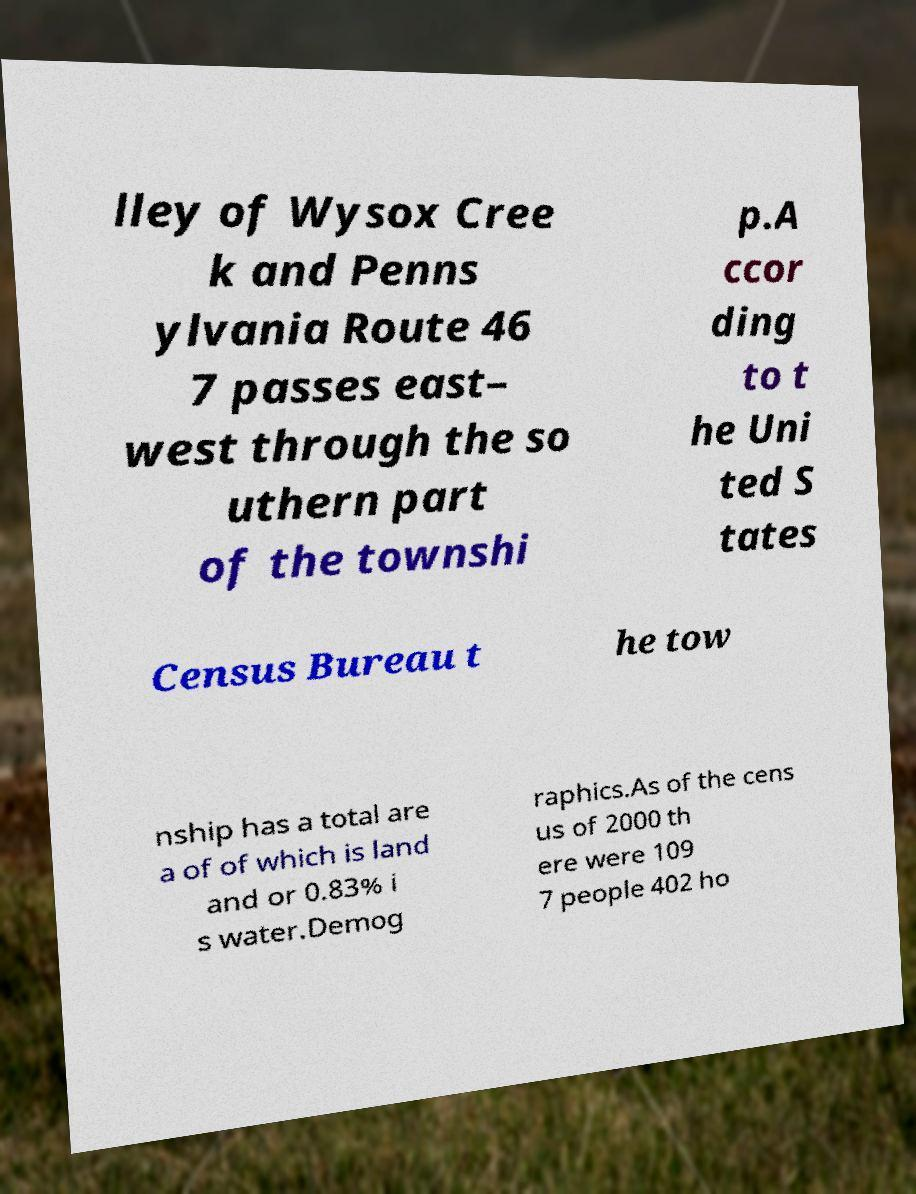For documentation purposes, I need the text within this image transcribed. Could you provide that? lley of Wysox Cree k and Penns ylvania Route 46 7 passes east– west through the so uthern part of the townshi p.A ccor ding to t he Uni ted S tates Census Bureau t he tow nship has a total are a of of which is land and or 0.83% i s water.Demog raphics.As of the cens us of 2000 th ere were 109 7 people 402 ho 